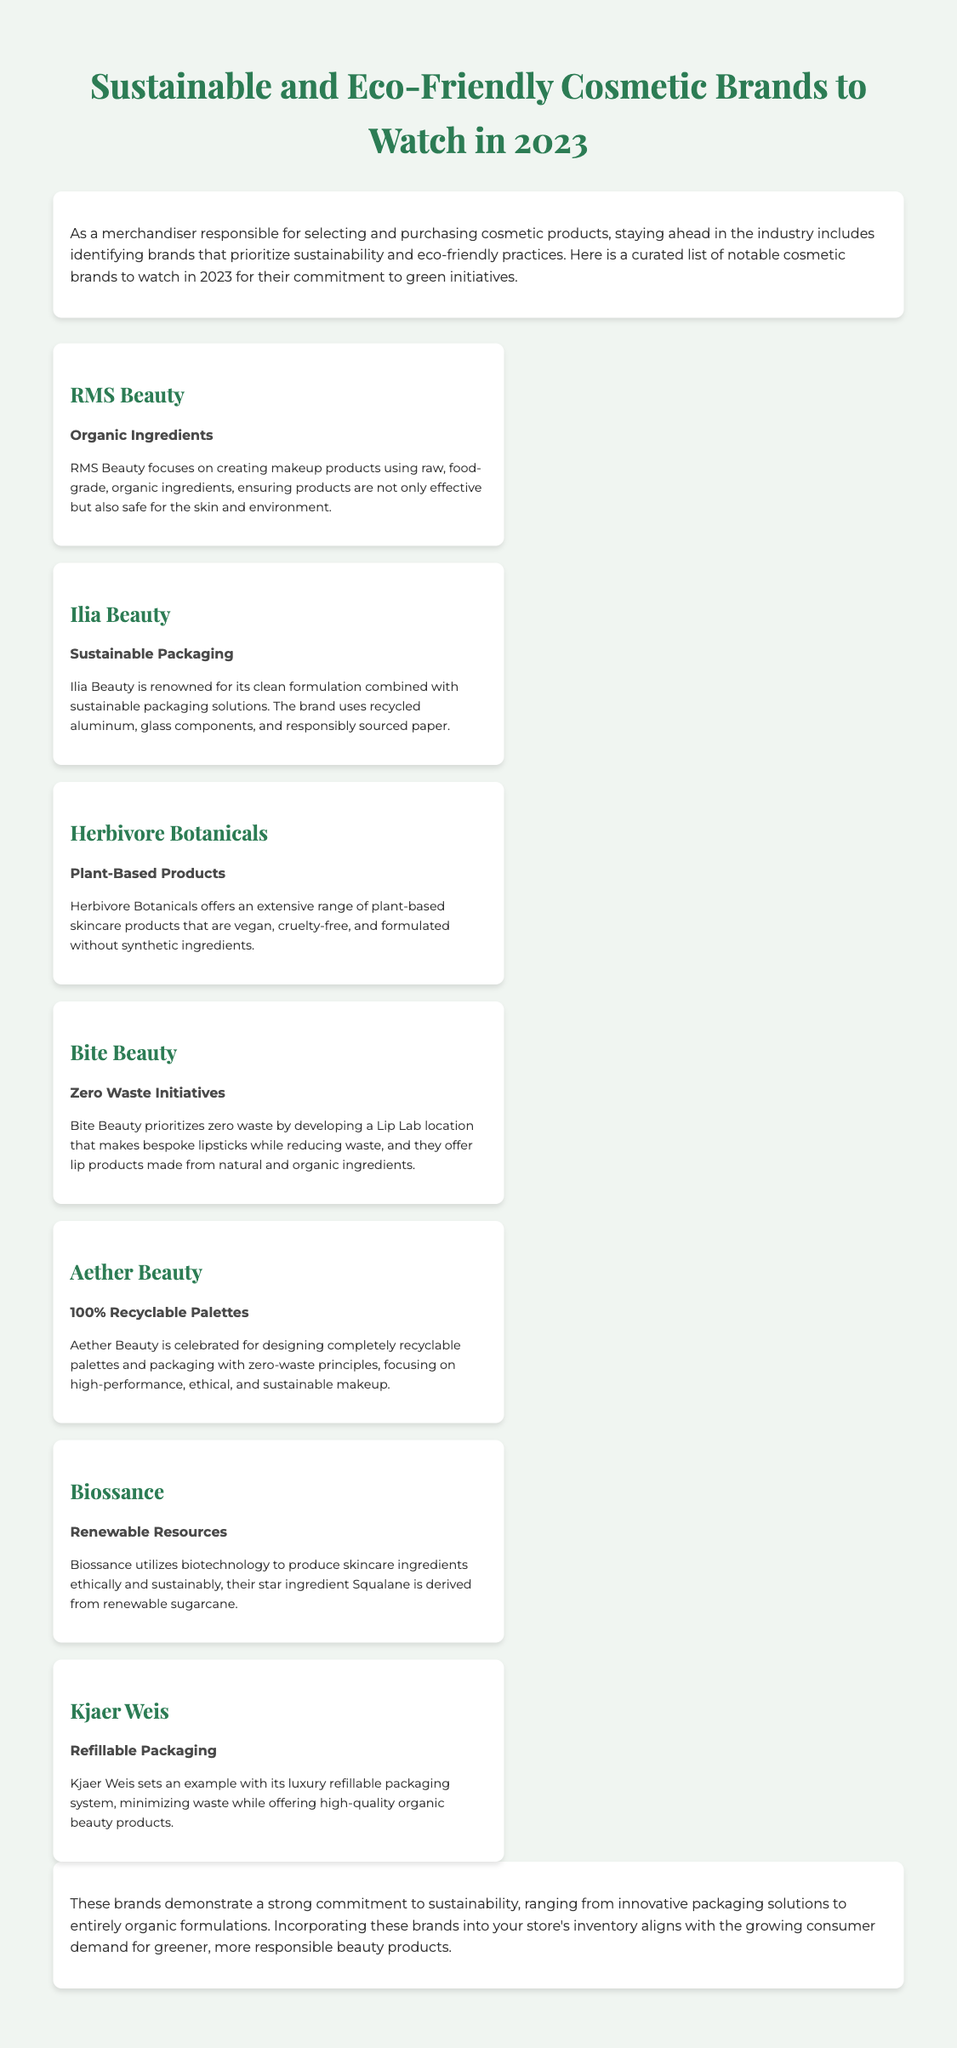What is the title of the infographic? The title of the infographic is indicated at the top of the document and summarizes its content about brands specializing in sustainability.
Answer: Sustainable and Eco-Friendly Cosmetic Brands to Watch in 2023 How many brands are mentioned in the document? The document includes a list that provides information on several cosmetic brands, which can be counted in the brands list section.
Answer: 7 Which brand highlights the use of organic ingredients? The specific brand that focuses on creating makeup products from raw, food-grade, organic ingredients is identified in the document.
Answer: RMS Beauty What sustainable practice is associated with Bite Beauty? The document states the specific initiative that Bite Beauty prioritizes concerning waste reduction.
Answer: Zero Waste Initiatives What type of packaging does Kjaer Weis use? The document mentions Kjaer Weis's unique approach to minimizing waste through their packaging system.
Answer: Refillable Packaging Which brand uses recycled materials in its packaging? The document specifically points out which brand incorporates recycled materials into its packaging.
Answer: Ilia Beauty What is the star ingredient listed for Biossance? The document specifies a key ingredient derived from renewable resources, emphasizing their sustainable approach.
Answer: Squalane Which brand is known for its 100% recyclable palettes? The document identifies a brand that is celebrated for its completely recyclable product design.
Answer: Aether Beauty 